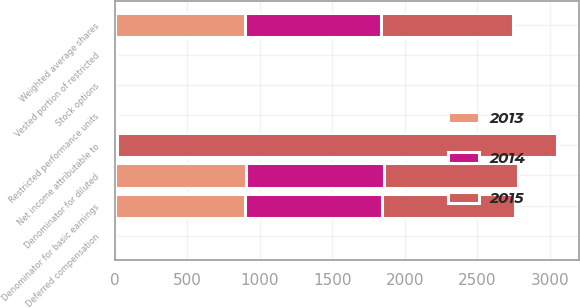Convert chart. <chart><loc_0><loc_0><loc_500><loc_500><stacked_bar_chart><ecel><fcel>Net income attributable to<fcel>Weighted average shares<fcel>Deferred compensation<fcel>Vested portion of restricted<fcel>Denominator for basic earnings<fcel>Restricted performance units<fcel>Stock options<fcel>Denominator for diluted<nl><fcel>2013<fcel>7<fcel>896<fcel>1<fcel>4<fcel>901<fcel>4<fcel>1<fcel>906<nl><fcel>2015<fcel>3032<fcel>913<fcel>1<fcel>2<fcel>916<fcel>7<fcel>1<fcel>924<nl><fcel>2014<fcel>7<fcel>937<fcel>1<fcel>2<fcel>940<fcel>7<fcel>1<fcel>948<nl></chart> 